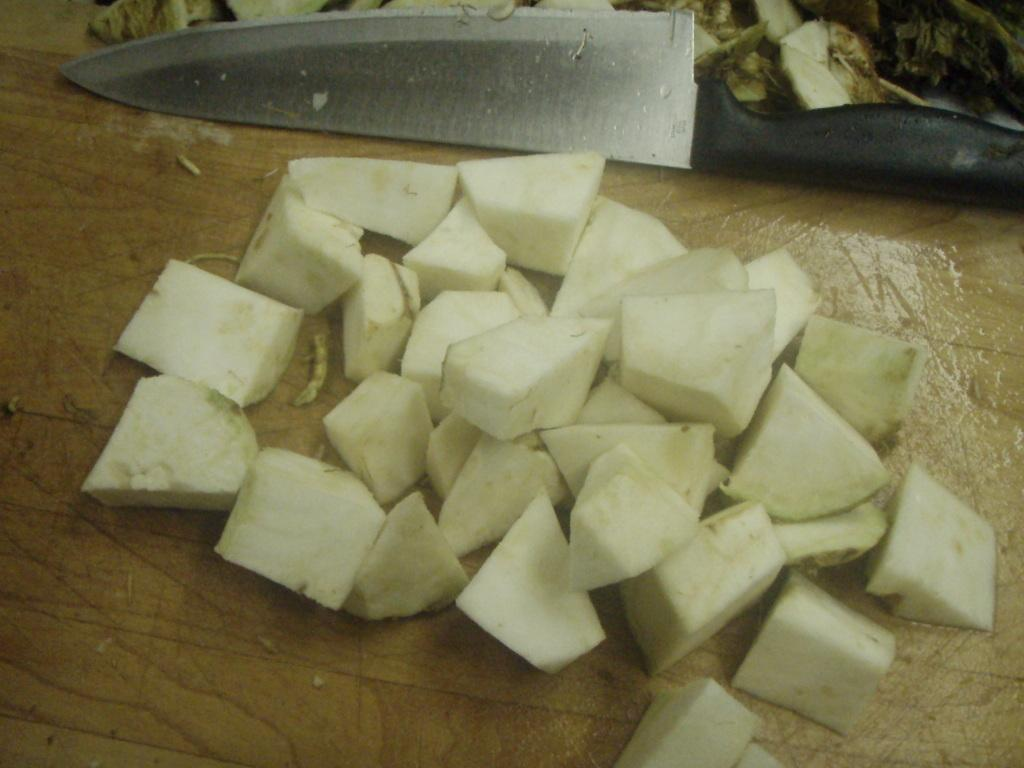What is the main subject in the center of the image? There are chopped vegetables in the center of the image. Where are the chopped vegetables located? The chopped vegetables are on a table. What tool is visible in the image? There is a knife visible in the image. Can you tell me where the receipt is located in the image? There is no receipt present in the image. What type of coastline can be seen in the background of the image? There is no coastline visible in the image; it features chopped vegetables on a table. 